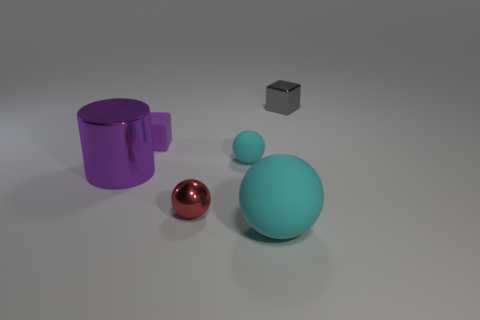Subtract all rubber balls. How many balls are left? 1 Subtract all brown cubes. How many cyan spheres are left? 2 Add 2 red balls. How many objects exist? 8 Subtract all purple blocks. How many blocks are left? 1 Subtract all cylinders. How many objects are left? 5 Add 3 shiny things. How many shiny things are left? 6 Add 1 tiny matte objects. How many tiny matte objects exist? 3 Subtract 0 green cylinders. How many objects are left? 6 Subtract all purple spheres. Subtract all purple cylinders. How many spheres are left? 3 Subtract all purple matte blocks. Subtract all gray things. How many objects are left? 4 